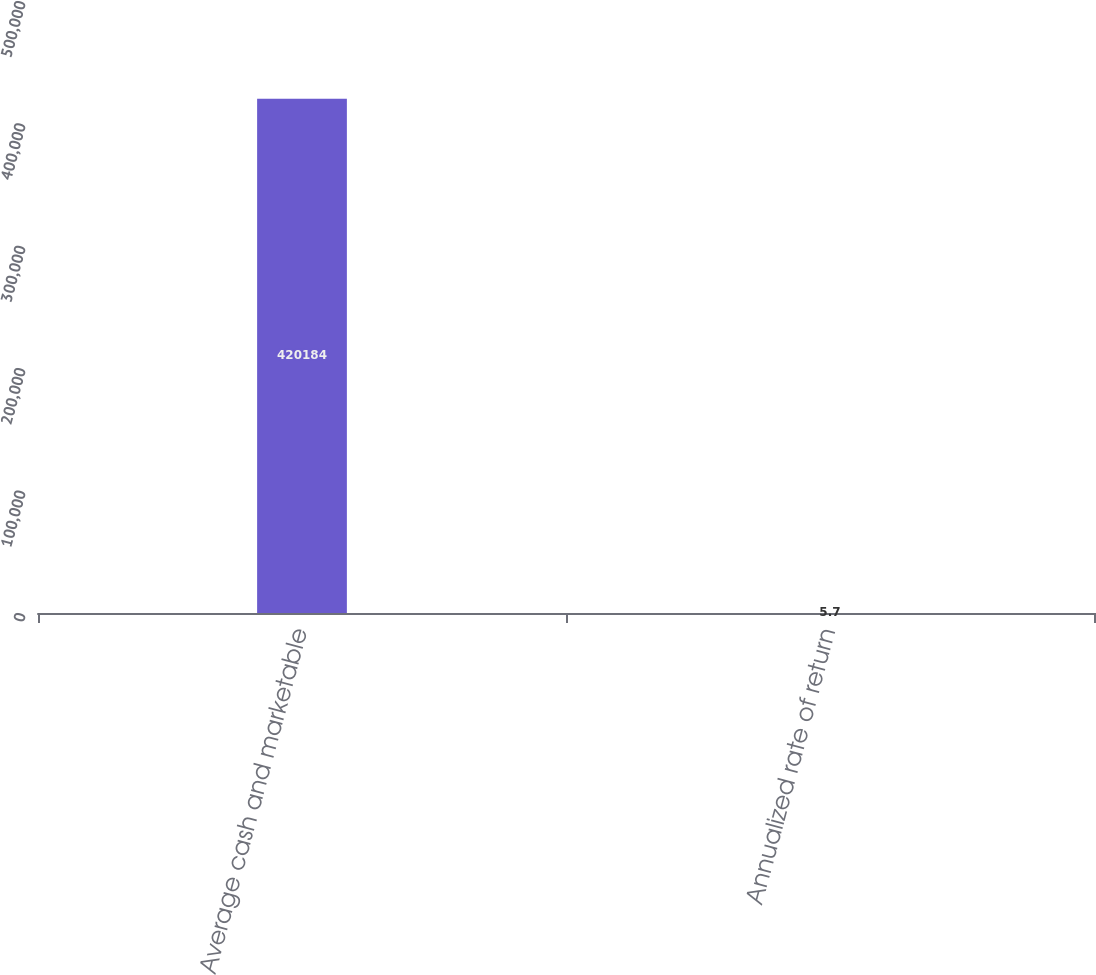<chart> <loc_0><loc_0><loc_500><loc_500><bar_chart><fcel>Average cash and marketable<fcel>Annualized rate of return<nl><fcel>420184<fcel>5.7<nl></chart> 